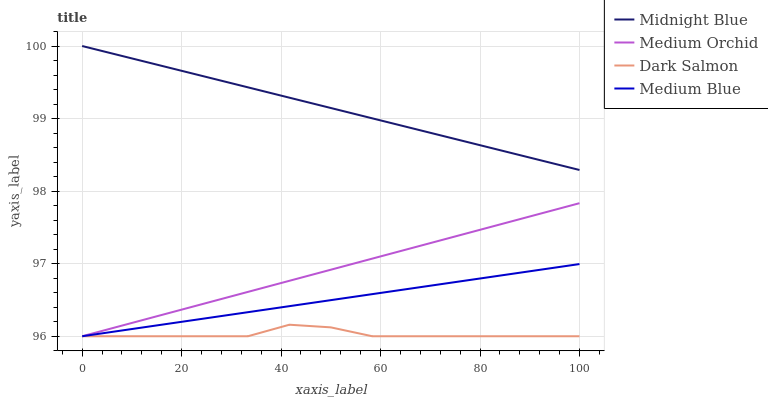Does Dark Salmon have the minimum area under the curve?
Answer yes or no. Yes. Does Midnight Blue have the maximum area under the curve?
Answer yes or no. Yes. Does Medium Blue have the minimum area under the curve?
Answer yes or no. No. Does Medium Blue have the maximum area under the curve?
Answer yes or no. No. Is Medium Blue the smoothest?
Answer yes or no. Yes. Is Dark Salmon the roughest?
Answer yes or no. Yes. Is Midnight Blue the smoothest?
Answer yes or no. No. Is Midnight Blue the roughest?
Answer yes or no. No. Does Medium Orchid have the lowest value?
Answer yes or no. Yes. Does Midnight Blue have the lowest value?
Answer yes or no. No. Does Midnight Blue have the highest value?
Answer yes or no. Yes. Does Medium Blue have the highest value?
Answer yes or no. No. Is Medium Blue less than Midnight Blue?
Answer yes or no. Yes. Is Midnight Blue greater than Medium Blue?
Answer yes or no. Yes. Does Medium Blue intersect Dark Salmon?
Answer yes or no. Yes. Is Medium Blue less than Dark Salmon?
Answer yes or no. No. Is Medium Blue greater than Dark Salmon?
Answer yes or no. No. Does Medium Blue intersect Midnight Blue?
Answer yes or no. No. 